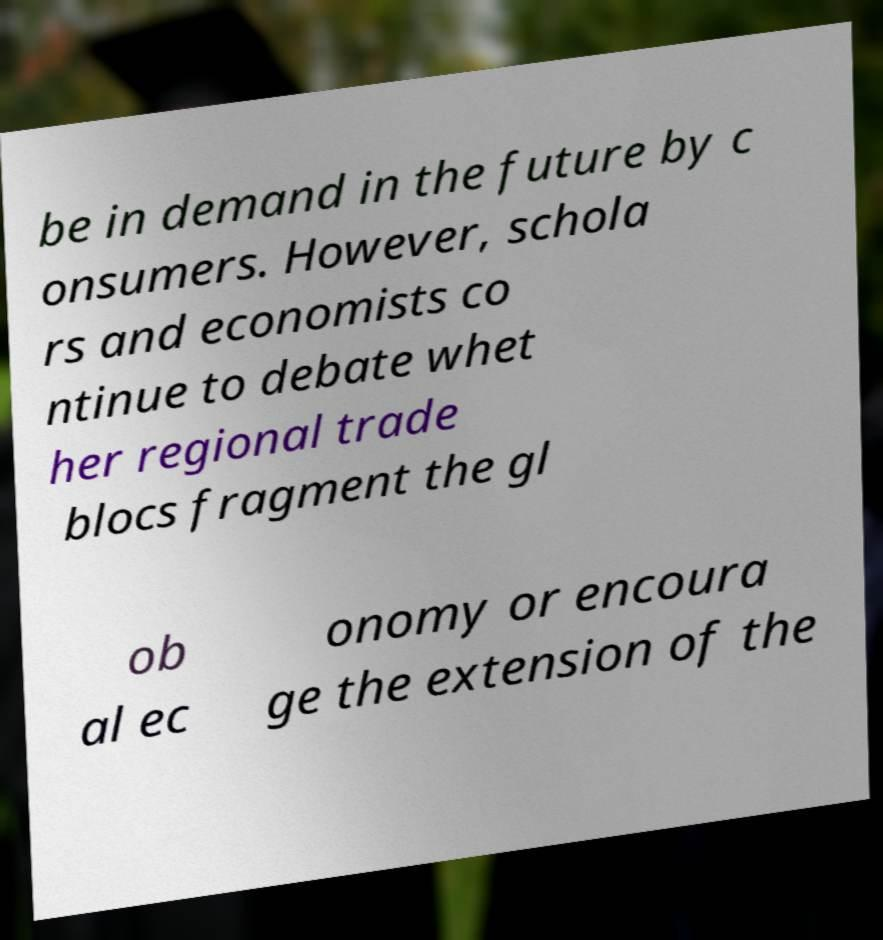Can you accurately transcribe the text from the provided image for me? be in demand in the future by c onsumers. However, schola rs and economists co ntinue to debate whet her regional trade blocs fragment the gl ob al ec onomy or encoura ge the extension of the 